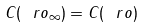Convert formula to latex. <formula><loc_0><loc_0><loc_500><loc_500>C ( \ r o _ { \infty } ) = C ( \ r o )</formula> 